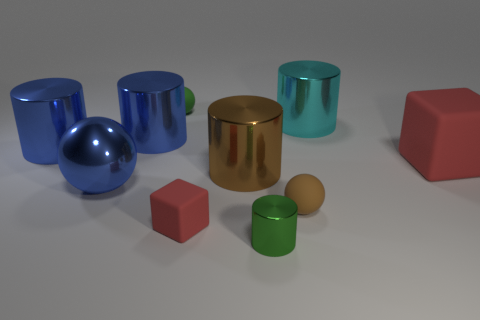Subtract all tiny cylinders. How many cylinders are left? 4 Subtract all brown cylinders. How many cylinders are left? 4 Subtract all yellow cylinders. Subtract all gray cubes. How many cylinders are left? 5 Subtract all balls. How many objects are left? 7 Subtract 1 cyan cylinders. How many objects are left? 9 Subtract all blue rubber balls. Subtract all big red rubber cubes. How many objects are left? 9 Add 6 big cyan shiny objects. How many big cyan shiny objects are left? 7 Add 4 big cyan shiny things. How many big cyan shiny things exist? 5 